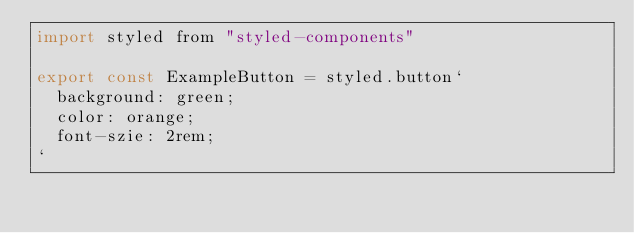Convert code to text. <code><loc_0><loc_0><loc_500><loc_500><_JavaScript_>import styled from "styled-components"

export const ExampleButton = styled.button`
  background: green;
  color: orange;
  font-szie: 2rem;
`
</code> 